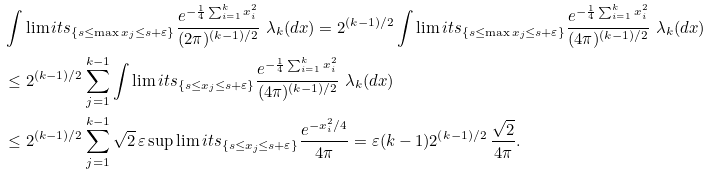Convert formula to latex. <formula><loc_0><loc_0><loc_500><loc_500>& \int \lim i t s _ { \{ s \leq \max x _ { j } \leq s + \varepsilon \} } \frac { e ^ { - \frac { 1 } { 4 } \sum _ { i = 1 } ^ { k } x _ { i } ^ { 2 } } } { ( 2 \pi ) ^ { ( k - 1 ) / 2 } } \ \lambda _ { k } ( d x ) = 2 ^ { ( k - 1 ) / 2 } \int \lim i t s _ { \{ s \leq \max x _ { j } \leq s + \varepsilon \} } \frac { e ^ { - \frac { 1 } { 4 } \sum _ { i = 1 } ^ { k } x _ { i } ^ { 2 } } } { ( 4 \pi ) ^ { ( k - 1 ) / 2 } } \ \lambda _ { k } ( d x ) \\ & \leq 2 ^ { ( k - 1 ) / 2 } \sum _ { j = 1 } ^ { k - 1 } \int \lim i t s _ { \{ s \leq x _ { j } \leq s + \varepsilon \} } \frac { e ^ { - \frac { 1 } { 4 } \sum _ { i = 1 } ^ { k } x _ { i } ^ { 2 } } } { ( 4 \pi ) ^ { ( k - 1 ) / 2 } } \ \lambda _ { k } ( d x ) \\ & \leq 2 ^ { ( k - 1 ) / 2 } \sum _ { j = 1 } ^ { k - 1 } \sqrt { 2 } \, \varepsilon \sup \lim i t s _ { \{ s \leq x _ { j } \leq s + \varepsilon \} } \frac { e ^ { - x _ { i } ^ { 2 } / 4 } } { 4 \pi } = \varepsilon ( k - 1 ) 2 ^ { ( k - 1 ) / 2 } \, \frac { \sqrt { 2 } } { 4 \pi } .</formula> 